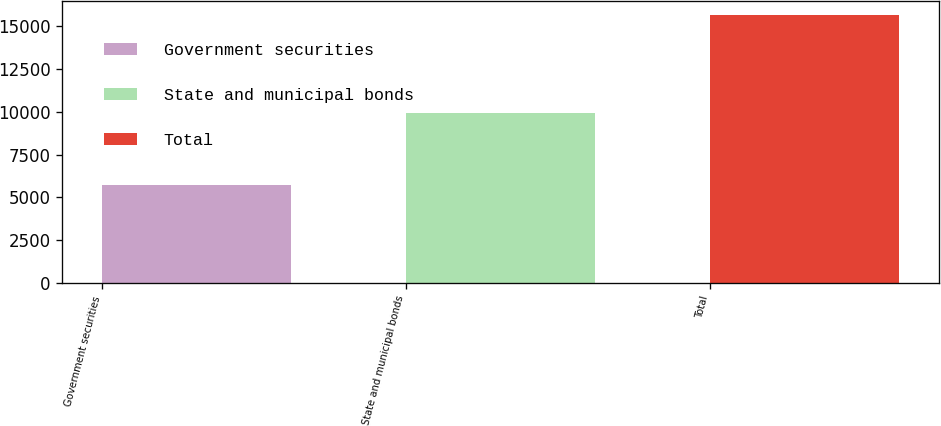Convert chart to OTSL. <chart><loc_0><loc_0><loc_500><loc_500><bar_chart><fcel>Government securities<fcel>State and municipal bonds<fcel>Total<nl><fcel>5755<fcel>9923<fcel>15678<nl></chart> 